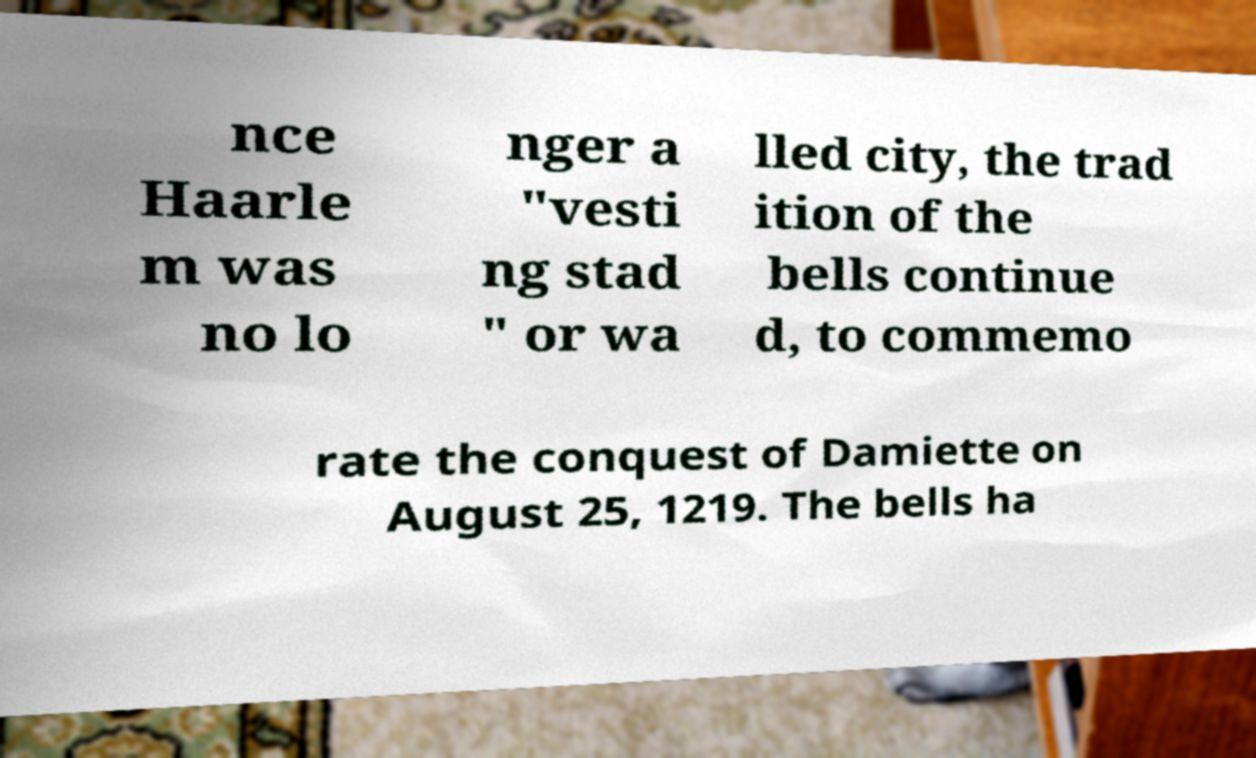What messages or text are displayed in this image? I need them in a readable, typed format. nce Haarle m was no lo nger a "vesti ng stad " or wa lled city, the trad ition of the bells continue d, to commemo rate the conquest of Damiette on August 25, 1219. The bells ha 